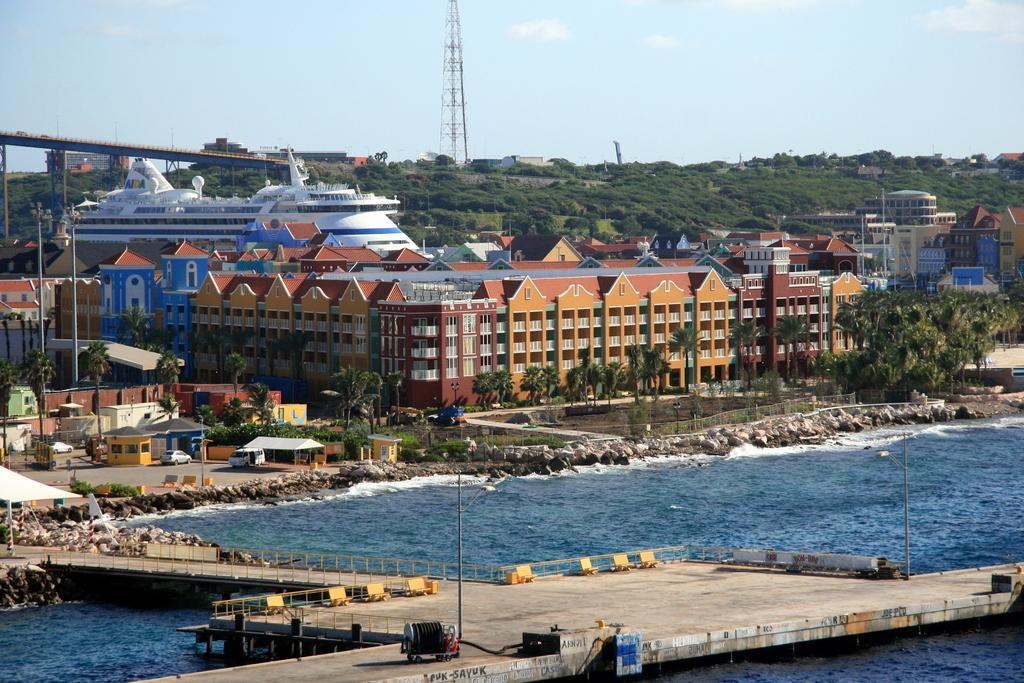How would you summarize this image in a sentence or two? In this image we can see the buildings, sheds and the water. We can see a ship. And we can see the surrounding trees, stones. We can see the bridge, few vehicles. There are clouds in the sky. 